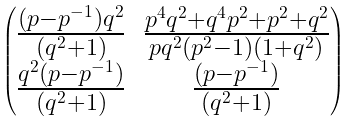<formula> <loc_0><loc_0><loc_500><loc_500>\begin{pmatrix} \frac { ( p - p ^ { - 1 } ) q ^ { 2 } } { ( q ^ { 2 } + 1 ) } & \frac { p ^ { 4 } q ^ { 2 } + q ^ { 4 } p ^ { 2 } + p ^ { 2 } + q ^ { 2 } } { p q ^ { 2 } ( p ^ { 2 } - 1 ) ( 1 + q ^ { 2 } ) } \\ \frac { q ^ { 2 } ( p - p ^ { - 1 } ) } { ( q ^ { 2 } + 1 ) } & \frac { ( p - p ^ { - 1 } ) } { ( q ^ { 2 } + 1 ) } \end{pmatrix}</formula> 